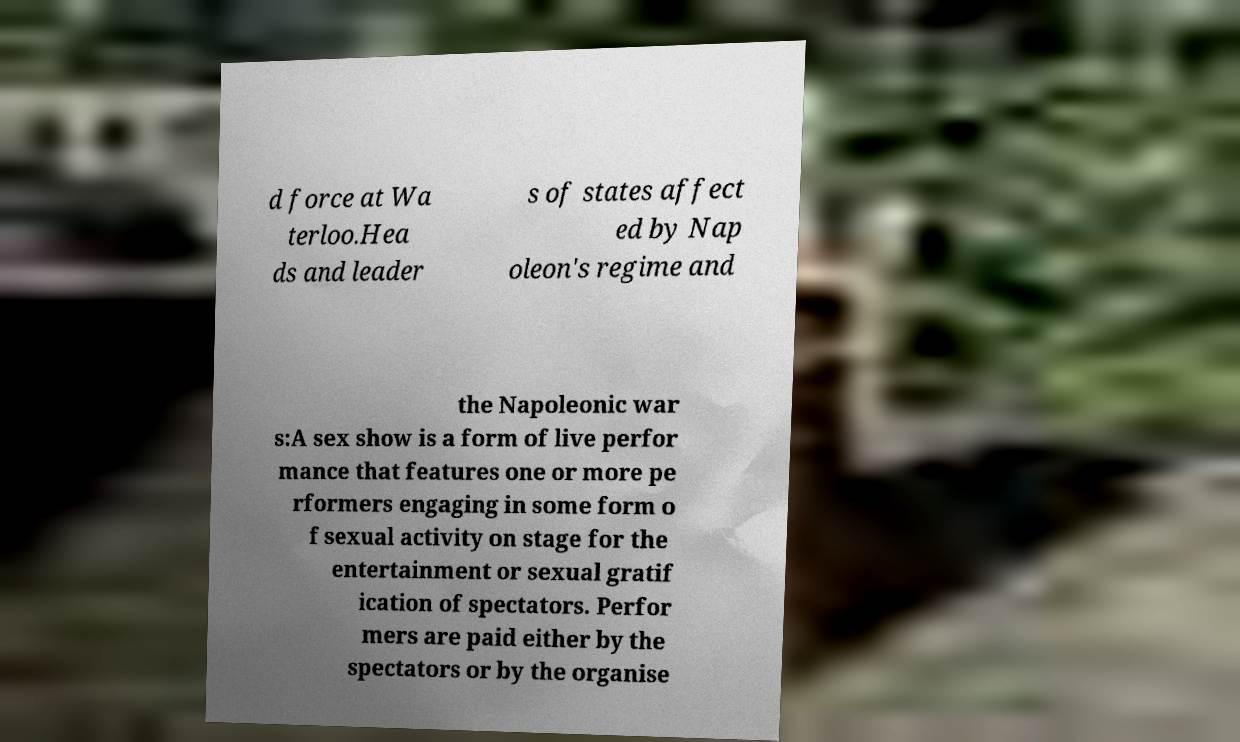There's text embedded in this image that I need extracted. Can you transcribe it verbatim? d force at Wa terloo.Hea ds and leader s of states affect ed by Nap oleon's regime and the Napoleonic war s:A sex show is a form of live perfor mance that features one or more pe rformers engaging in some form o f sexual activity on stage for the entertainment or sexual gratif ication of spectators. Perfor mers are paid either by the spectators or by the organise 